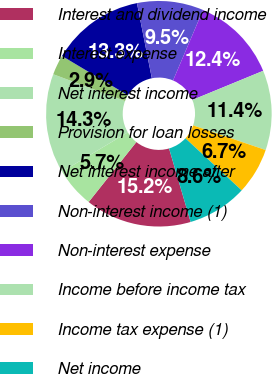<chart> <loc_0><loc_0><loc_500><loc_500><pie_chart><fcel>Interest and dividend income<fcel>Interest expense<fcel>Net interest income<fcel>Provision for loan losses<fcel>Net interest income after<fcel>Non-interest income (1)<fcel>Non-interest expense<fcel>Income before income tax<fcel>Income tax expense (1)<fcel>Net income<nl><fcel>15.24%<fcel>5.72%<fcel>14.28%<fcel>2.86%<fcel>13.33%<fcel>9.52%<fcel>12.38%<fcel>11.43%<fcel>6.67%<fcel>8.57%<nl></chart> 